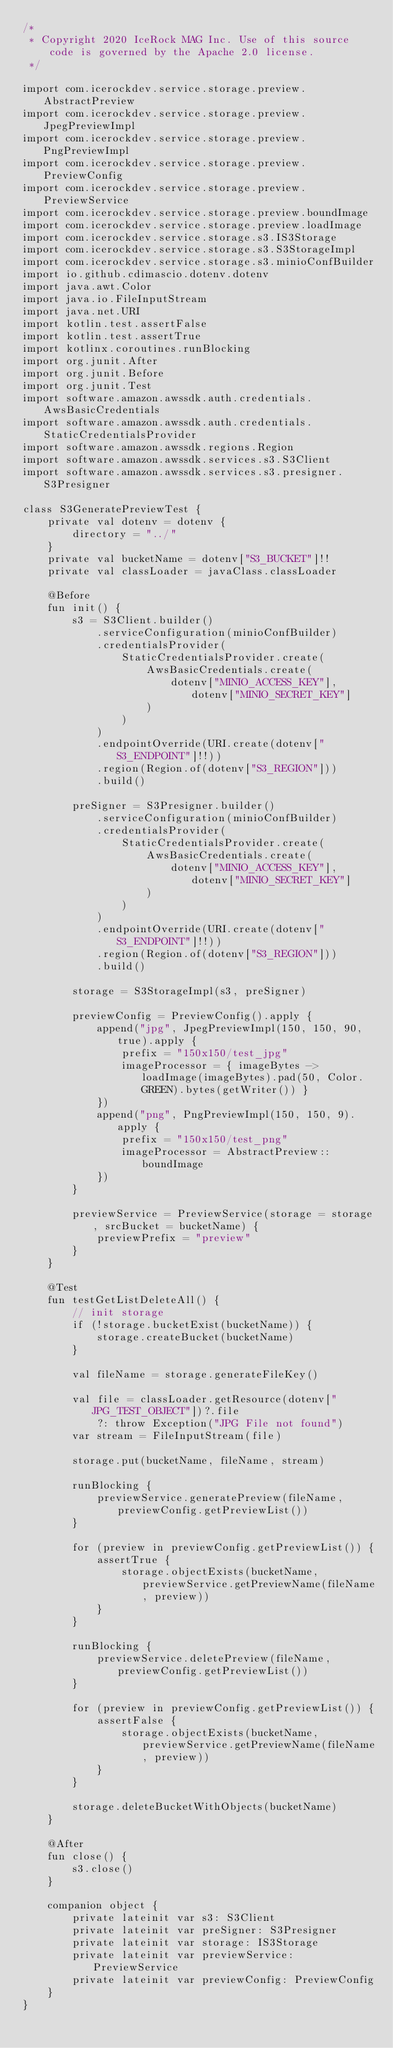<code> <loc_0><loc_0><loc_500><loc_500><_Kotlin_>/*
 * Copyright 2020 IceRock MAG Inc. Use of this source code is governed by the Apache 2.0 license.
 */

import com.icerockdev.service.storage.preview.AbstractPreview
import com.icerockdev.service.storage.preview.JpegPreviewImpl
import com.icerockdev.service.storage.preview.PngPreviewImpl
import com.icerockdev.service.storage.preview.PreviewConfig
import com.icerockdev.service.storage.preview.PreviewService
import com.icerockdev.service.storage.preview.boundImage
import com.icerockdev.service.storage.preview.loadImage
import com.icerockdev.service.storage.s3.IS3Storage
import com.icerockdev.service.storage.s3.S3StorageImpl
import com.icerockdev.service.storage.s3.minioConfBuilder
import io.github.cdimascio.dotenv.dotenv
import java.awt.Color
import java.io.FileInputStream
import java.net.URI
import kotlin.test.assertFalse
import kotlin.test.assertTrue
import kotlinx.coroutines.runBlocking
import org.junit.After
import org.junit.Before
import org.junit.Test
import software.amazon.awssdk.auth.credentials.AwsBasicCredentials
import software.amazon.awssdk.auth.credentials.StaticCredentialsProvider
import software.amazon.awssdk.regions.Region
import software.amazon.awssdk.services.s3.S3Client
import software.amazon.awssdk.services.s3.presigner.S3Presigner

class S3GeneratePreviewTest {
    private val dotenv = dotenv {
        directory = "../"
    }
    private val bucketName = dotenv["S3_BUCKET"]!!
    private val classLoader = javaClass.classLoader

    @Before
    fun init() {
        s3 = S3Client.builder()
            .serviceConfiguration(minioConfBuilder)
            .credentialsProvider(
                StaticCredentialsProvider.create(
                    AwsBasicCredentials.create(
                        dotenv["MINIO_ACCESS_KEY"], dotenv["MINIO_SECRET_KEY"]
                    )
                )
            )
            .endpointOverride(URI.create(dotenv["S3_ENDPOINT"]!!))
            .region(Region.of(dotenv["S3_REGION"]))
            .build()

        preSigner = S3Presigner.builder()
            .serviceConfiguration(minioConfBuilder)
            .credentialsProvider(
                StaticCredentialsProvider.create(
                    AwsBasicCredentials.create(
                        dotenv["MINIO_ACCESS_KEY"], dotenv["MINIO_SECRET_KEY"]
                    )
                )
            )
            .endpointOverride(URI.create(dotenv["S3_ENDPOINT"]!!))
            .region(Region.of(dotenv["S3_REGION"]))
            .build()

        storage = S3StorageImpl(s3, preSigner)

        previewConfig = PreviewConfig().apply {
            append("jpg", JpegPreviewImpl(150, 150, 90, true).apply {
                prefix = "150x150/test_jpg"
                imageProcessor = { imageBytes -> loadImage(imageBytes).pad(50, Color.GREEN).bytes(getWriter()) }
            })
            append("png", PngPreviewImpl(150, 150, 9).apply {
                prefix = "150x150/test_png"
                imageProcessor = AbstractPreview::boundImage
            })
        }

        previewService = PreviewService(storage = storage, srcBucket = bucketName) {
            previewPrefix = "preview"
        }
    }

    @Test
    fun testGetListDeleteAll() {
        // init storage
        if (!storage.bucketExist(bucketName)) {
            storage.createBucket(bucketName)
        }

        val fileName = storage.generateFileKey()

        val file = classLoader.getResource(dotenv["JPG_TEST_OBJECT"])?.file
            ?: throw Exception("JPG File not found")
        var stream = FileInputStream(file)

        storage.put(bucketName, fileName, stream)

        runBlocking {
            previewService.generatePreview(fileName, previewConfig.getPreviewList())
        }

        for (preview in previewConfig.getPreviewList()) {
            assertTrue {
                storage.objectExists(bucketName, previewService.getPreviewName(fileName, preview))
            }
        }

        runBlocking {
            previewService.deletePreview(fileName, previewConfig.getPreviewList())
        }

        for (preview in previewConfig.getPreviewList()) {
            assertFalse {
                storage.objectExists(bucketName, previewService.getPreviewName(fileName, preview))
            }
        }

        storage.deleteBucketWithObjects(bucketName)
    }

    @After
    fun close() {
        s3.close()
    }

    companion object {
        private lateinit var s3: S3Client
        private lateinit var preSigner: S3Presigner
        private lateinit var storage: IS3Storage
        private lateinit var previewService: PreviewService
        private lateinit var previewConfig: PreviewConfig
    }
}
</code> 